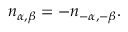<formula> <loc_0><loc_0><loc_500><loc_500>n _ { \alpha , \beta } = - n _ { - \alpha , - \beta } .</formula> 